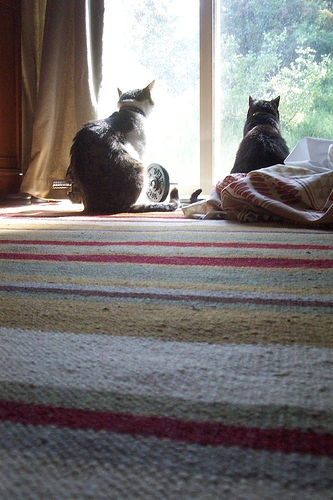Describe the objects in this image and their specific colors. I can see cat in black, gray, darkgray, and lightgray tones and cat in black, gray, ivory, and darkgray tones in this image. 